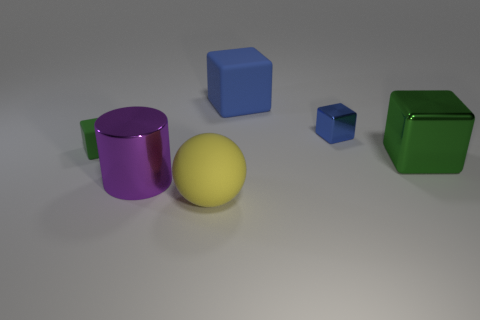Is the big matte block the same color as the small shiny object?
Offer a very short reply. Yes. The large metallic block has what color?
Your answer should be very brief. Green. What number of metallic objects are either tiny cyan cylinders or large yellow objects?
Ensure brevity in your answer.  0. There is a matte thing in front of the small object left of the purple metal cylinder that is behind the rubber ball; how big is it?
Make the answer very short. Large. How big is the object that is both on the right side of the large yellow sphere and on the left side of the small blue metal object?
Offer a very short reply. Large. There is a large metal object right of the big purple shiny cylinder; is its color the same as the small thing that is on the right side of the purple shiny thing?
Provide a succinct answer. No. There is a large yellow rubber object; what number of big purple cylinders are left of it?
Offer a terse response. 1. There is a metal object that is behind the big thing that is on the right side of the large blue block; are there any yellow rubber spheres that are to the right of it?
Your response must be concise. No. How many purple cylinders are the same size as the green shiny thing?
Your answer should be compact. 1. There is a large blue block that is behind the green thing that is behind the large green cube; what is its material?
Your response must be concise. Rubber. 